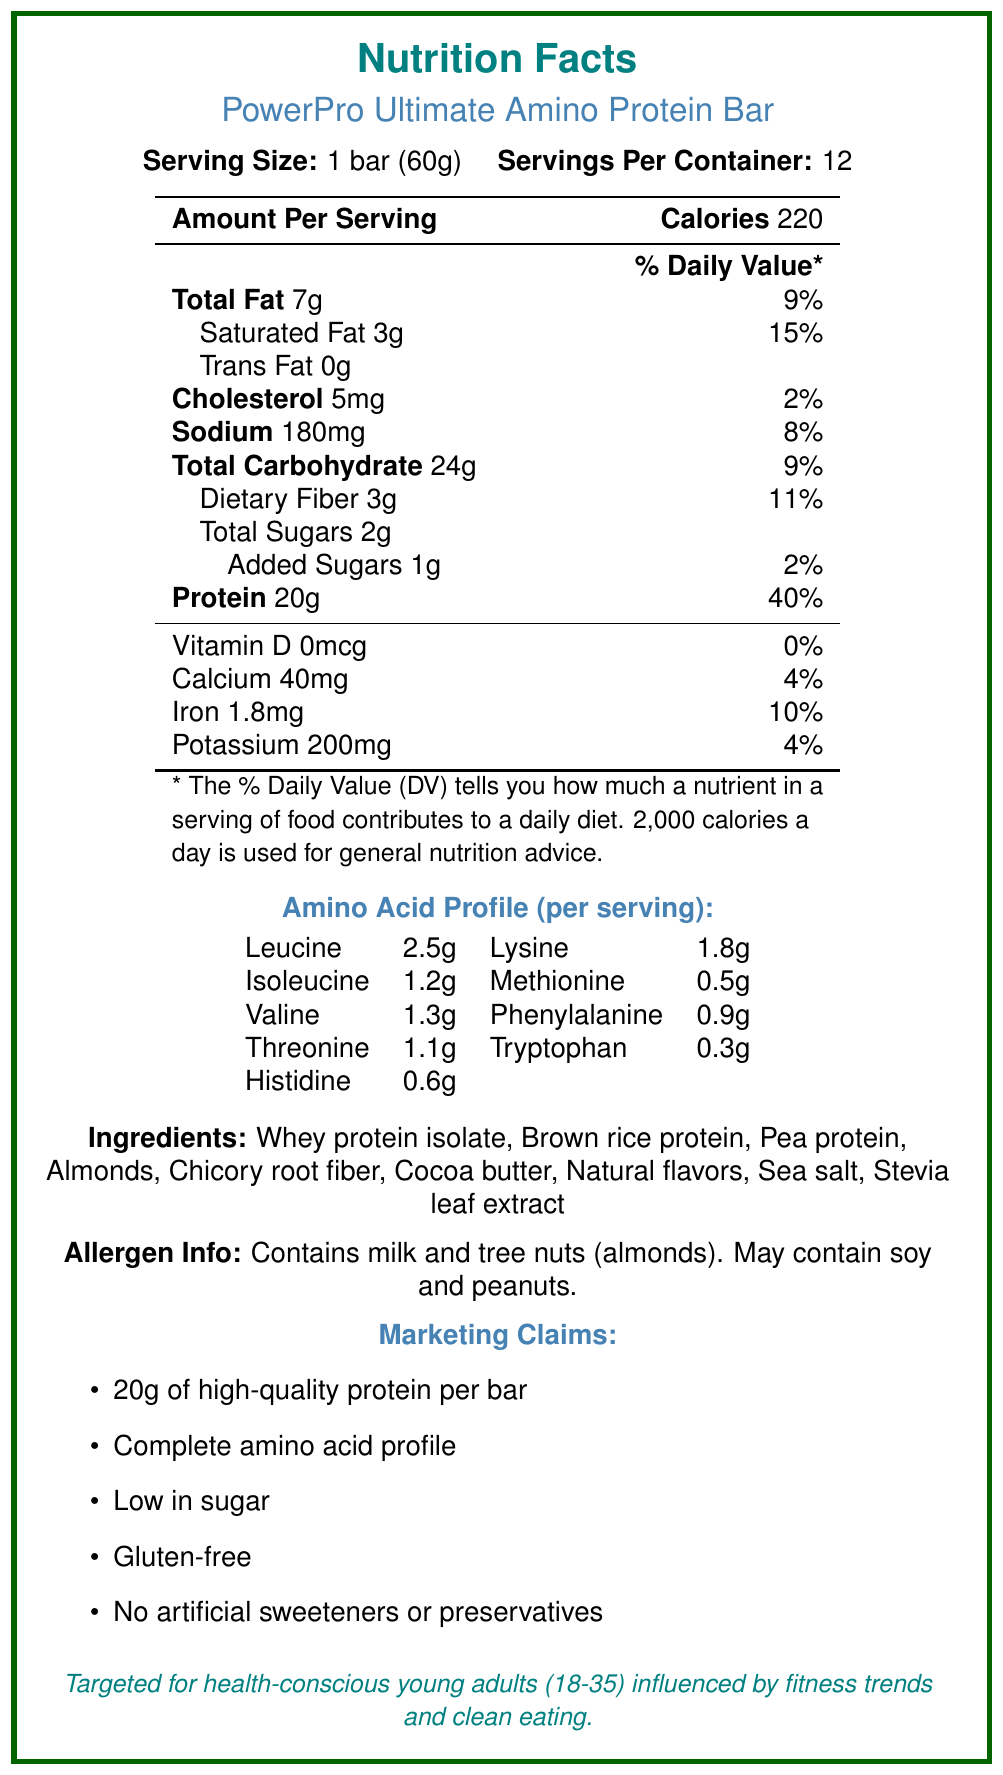what is the serving size of the protein bar? The document states that each serving size is 1 bar, which weighs 60 grams.
Answer: 1 bar (60g) how many servings are there per container? According to the document, each container contains 12 servings.
Answer: 12 how many grams of protein does a serving of the protein bar contain? The document states that there are 20 grams of protein per serving.
Answer: 20g what is the daily value percentage for dietary fiber in a serving? The document lists the daily value percentage for dietary fiber as 11%.
Answer: 11% what allergens are present in the protein bar? The document specifies that the protein bar contains milk and tree nuts (almonds).
Answer: Milk and tree nuts (almonds) what is the calorie count per serving? The document specifies that each serving (1 bar) contains 220 calories.
Answer: 220 which vitamin has 0% daily value in the protein bar? A. Vitamin D B. Calcium C. Iron D. Potassium The document shows that Vitamin D has 0 micrograms and 0% daily value, while Calcium, Iron, and Potassium have non-zero amounts and percentages.
Answer: A how many grams of total sugars does a serving contain? The document specifies that each serving contains 2 grams of total sugars.
Answer: 2g how much sodium is in each serving (in mg)? A. 180mg B. 200mg C. 150mg D. 220mg The document states that there are 180mg of sodium per serving.
Answer: A is the protein bar gluten-free? The marketing claims listed in the document state that the protein bar is gluten-free.
Answer: Yes summarize the main idea of the document. The document provides nutritional information, marketing claims, and sociological context targeting young adults focused on health and fitness.
Answer: The PowerPro Ultimate Amino Protein Bar's nutrition facts label details its high-protein content, complete amino acid profile, and suitability for health-conscious, fitness-oriented young adults. The bar contains 220 calories, 20g of protein, and various other nutrients. It is marketed as gluten-free, low in sugar, and contains no artificial sweeteners or preservatives. The product is also noted for containing common allergens such as milk and almonds. why might young adults aged 18-35 be interested in this protein bar? According to the document, the bar aligns with the preferences of young adults who are health-conscious, fitness-oriented, and often seek convenient, nutrient-dense snacks. The marketing strategy focuses on modern fitness culture and clean eating trends.
Answer: It's marketed as convenient and nutrient-dense, aimed at health-conscious, fitness-oriented individuals who prefer transparent nutritional information and are influenced by social media trends. how much methionine is there per serving of the protein bar? The amino acid profile in the document states that each bar contains 0.5 grams of methionine.
Answer: 0.5g which ingredient is used as a sweetener in the protein bar? The document lists Stevia leaf extract as one of the ingredients, indicating it is used as a sweetener.
Answer: Stevia leaf extract which nutrient has the highest daily value percentage in the protein bar? Among the listed nutrients, protein has the highest daily value percentage at 40%.
Answer: Protein, with 40% is the protein bar low in carbohydrates? The document does not provide enough context to determine if 24g of carbohydrates per serving qualifies as "low" in carbohydrates, as this can vary by dietary guidelines.
Answer: Not enough information Explain why the protein bar is labeled as having a "complete amino acid profile". The document lists an amino acid profile comprising all essential amino acids, which is a requirement for a "complete amino acid profile."
Answer: The bar contains all essential amino acids including leucine, isoleucine, valine, lysine, methionine, phenylalanine, threonine, tryptophan, and histidine. how many calories would be consumed if you ate two bars in one day? Each bar contains 220 calories, so eating two bars would total 440 calories (220 calories per bar x 2 bars).
Answer: 440 calories 